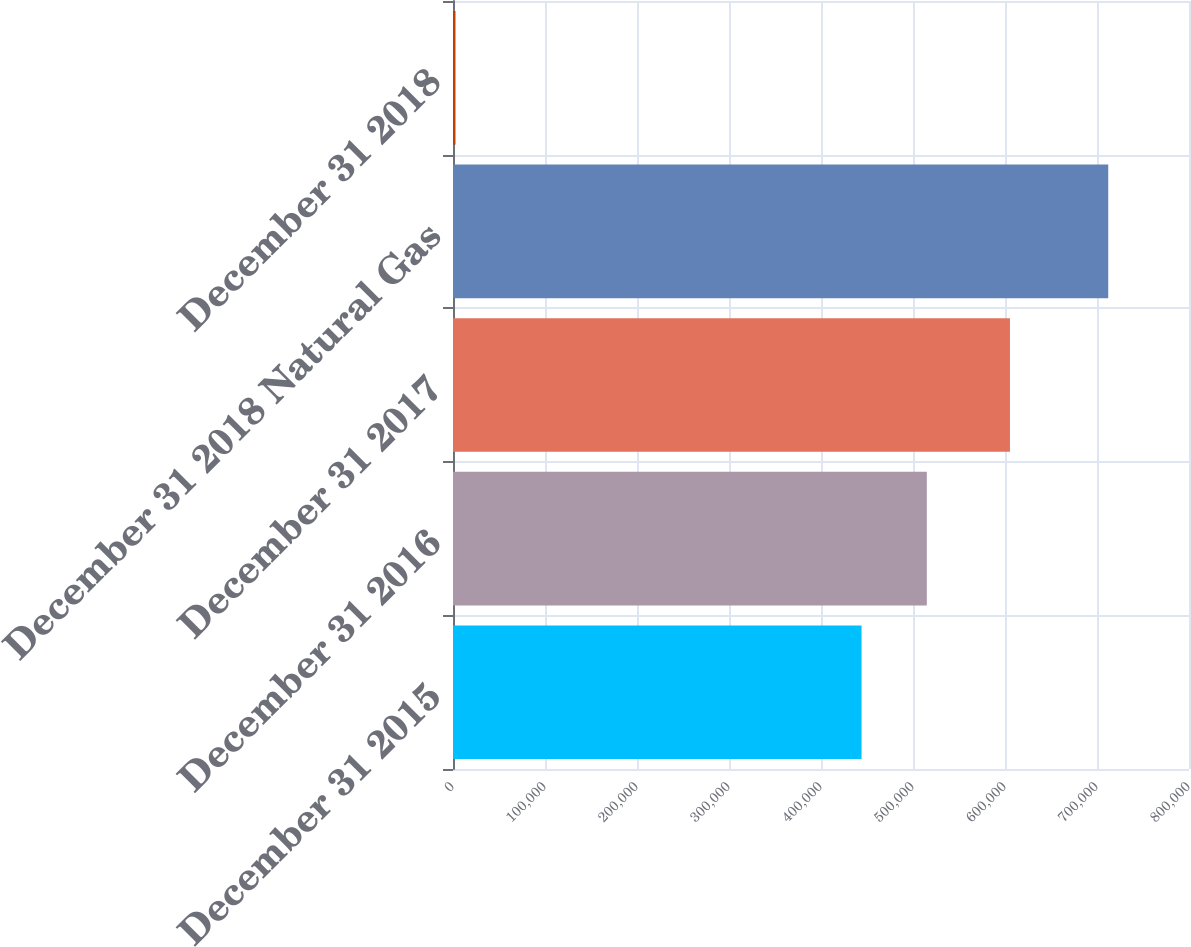Convert chart. <chart><loc_0><loc_0><loc_500><loc_500><bar_chart><fcel>December 31 2015<fcel>December 31 2016<fcel>December 31 2017<fcel>December 31 2018 Natural Gas<fcel>December 31 2018<nl><fcel>444070<fcel>515022<fcel>605405<fcel>712218<fcel>2699<nl></chart> 